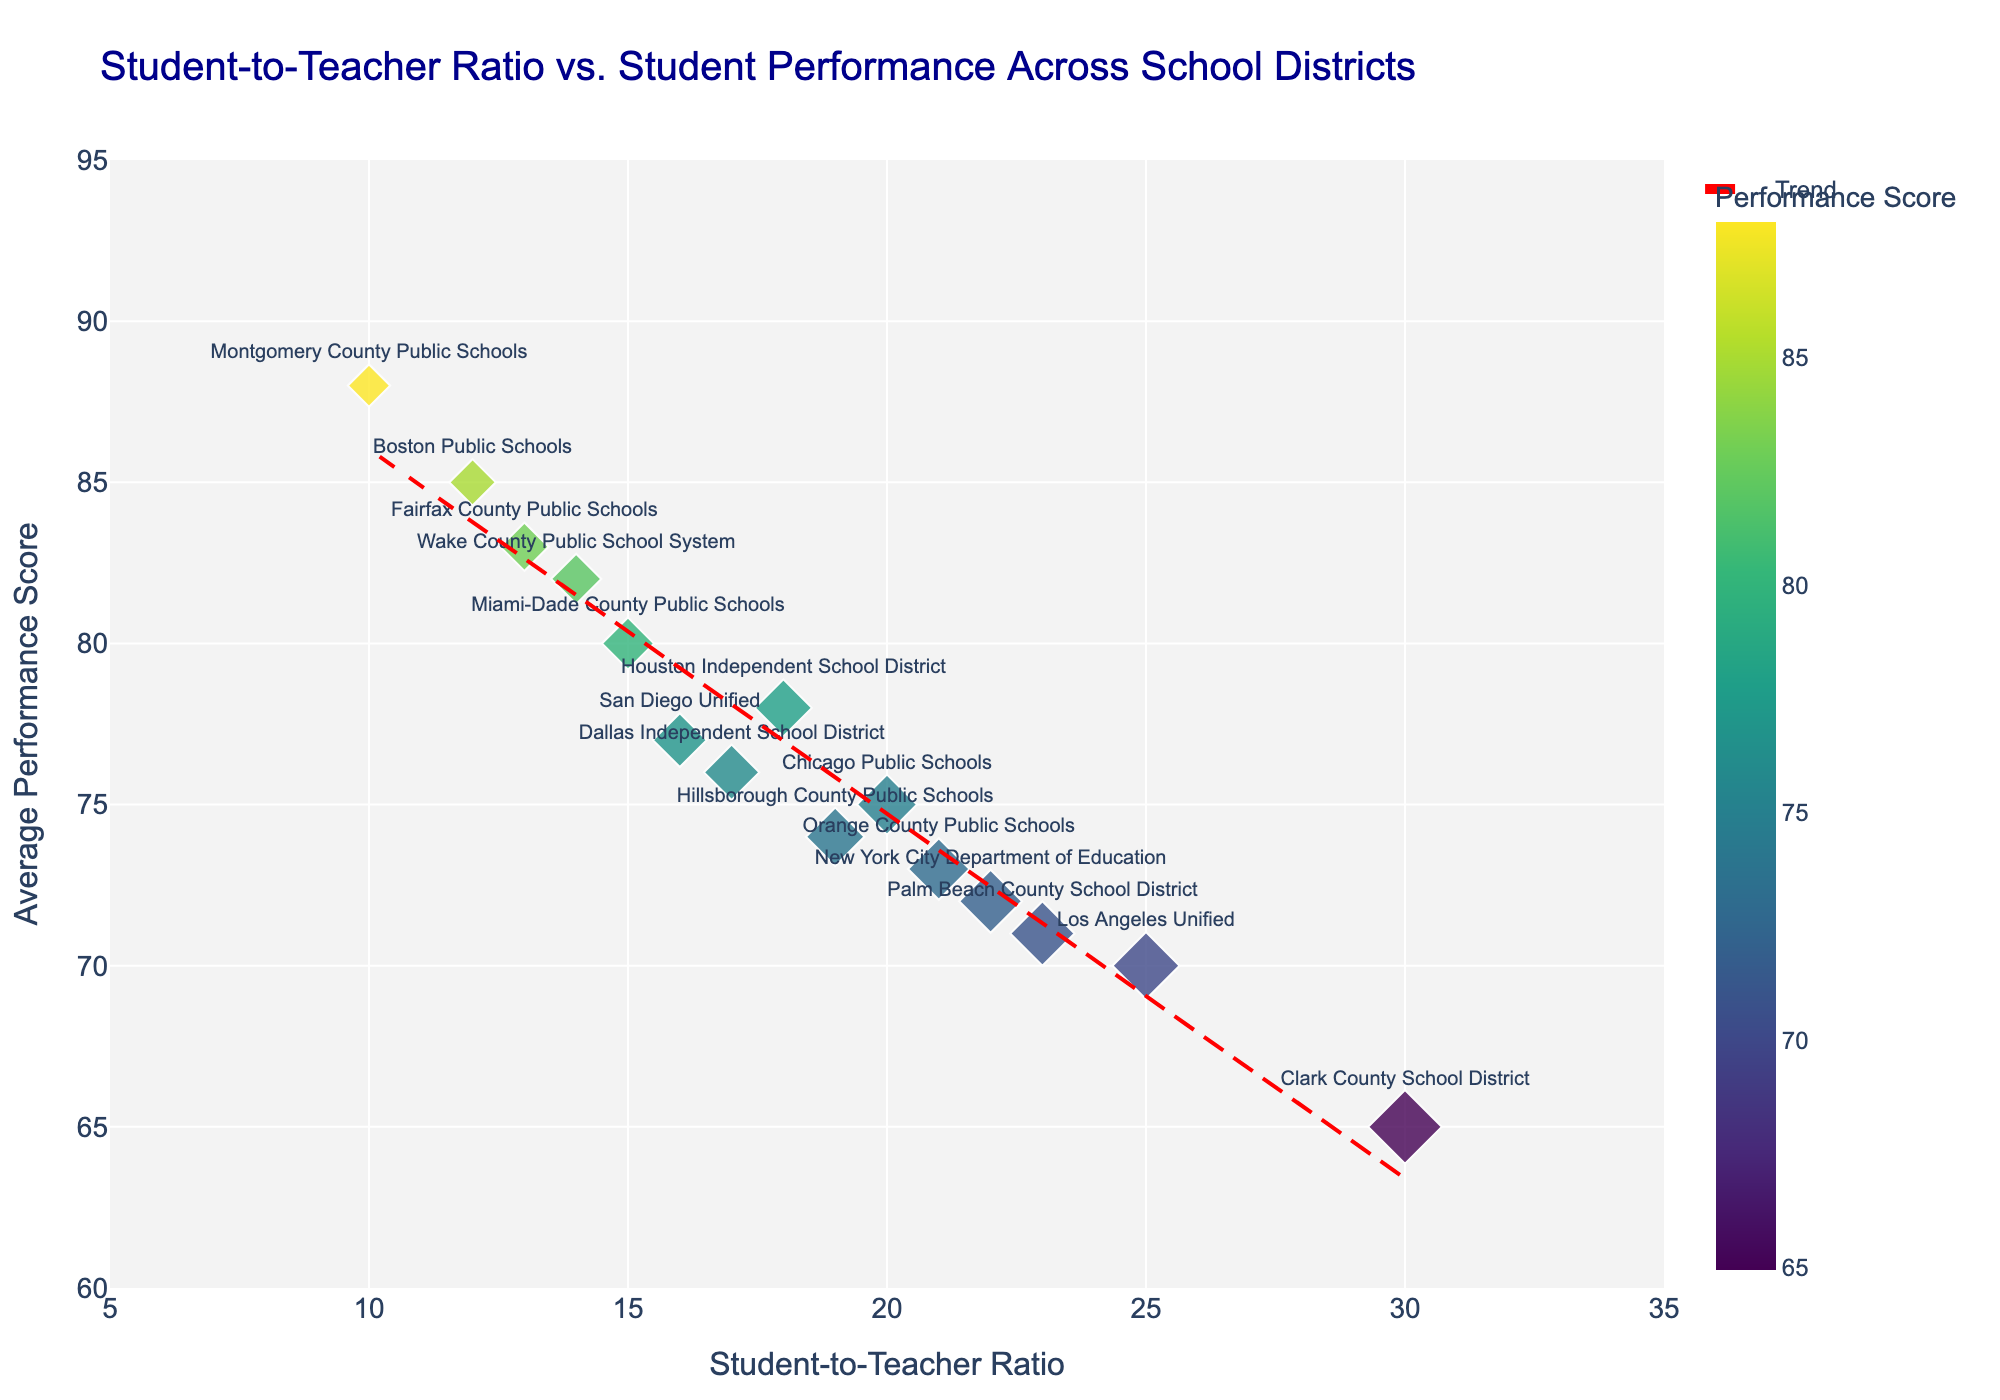What is the title of the scatter plot? The title of the scatter plot is typically displayed at the top of the figure. In this case, the title is "Student-to-Teacher Ratio vs. Student Performance Across School Districts."
Answer: Student-to-Teacher Ratio vs. Student Performance Across School Districts What is the performance score for Boston Public Schools? Locate the Boston Public Schools data point on the scatter plot, which should be labeled with the school's name. The vertical position of this point corresponds to its performance score.
Answer: 85 Which school district has the lowest student-to-teacher ratio, and what is its performance score? By identifying the data point furthest to the left on the x-axis, we find Montgomery County Public Schools. Checking the vertical position, we see its performance score.
Answer: Montgomery County Public Schools, 88 What's the difference in performance scores between New York City Department of Education and Fairfax County Public Schools? New York City's performance score is 72, and Fairfax's is 83. Subtract 72 from 83 to get the difference.
Answer: 11 What is the average student-to-teacher ratio of the school districts shown? Sum all the student-to-teacher ratios (12, 25, 20, 18, 15, 22, 30, 17, 13, 16, 19, 21, 14, 23, 10) and divide by the number of districts (15). (12 + 25 + 20 + 18 + 15 + 22 + 30 + 17 + 13 + 16 + 19 + 21 + 14 + 23 + 10) / 15 = 275 / 15.
Answer: 18.33 Which school district has the highest student-to-teacher ratio, and what is its performance score? Locate the data point furthest to the right on the x-axis. This point represents Clark County School District with a 30 ratio. By observing the vertical position, the performance score is found.
Answer: Clark County School District, 65 What trend does the red dashed line represent in the scatter plot? The red dashed line represents a trend line fitted to the scatter plot data. This trend line indicates the overall relationship between student-to-teacher ratio and performance score, demonstrating a downward trend (as the ratio increases, performance scores tend to decrease).
Answer: Downward trend Which school district has a student-to-teacher ratio closest to 20, and what is its performance score? Look for the data point near 20 on the x-axis. Chicago Public Schools matches this ratio. The corresponding performance score is observed vertically.
Answer: Chicago Public Schools, 75 